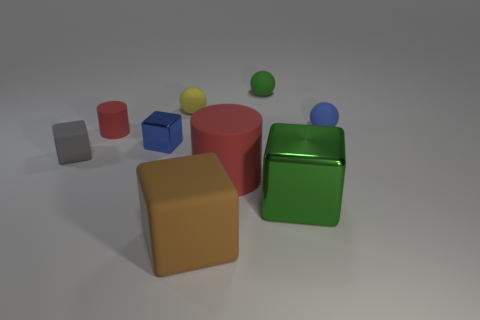There is a big rubber cylinder; is its color the same as the matte cylinder that is behind the large red cylinder?
Your answer should be very brief. Yes. The rubber object that is the same color as the large shiny object is what size?
Your response must be concise. Small. How many small rubber cylinders have the same color as the big rubber cylinder?
Provide a succinct answer. 1. There is a small thing that is the same color as the large metal cube; what is it made of?
Provide a short and direct response. Rubber. Is the blue metal cube the same size as the brown thing?
Offer a terse response. No. What is the color of the rubber cube that is left of the metal thing behind the large green cube?
Your answer should be very brief. Gray. How many other things are there of the same color as the small rubber cube?
Keep it short and to the point. 0. What number of things are either red rubber things or blocks that are in front of the big red object?
Give a very brief answer. 4. What is the color of the metal block behind the gray object?
Offer a very short reply. Blue. What is the shape of the small red matte thing?
Ensure brevity in your answer.  Cylinder. 